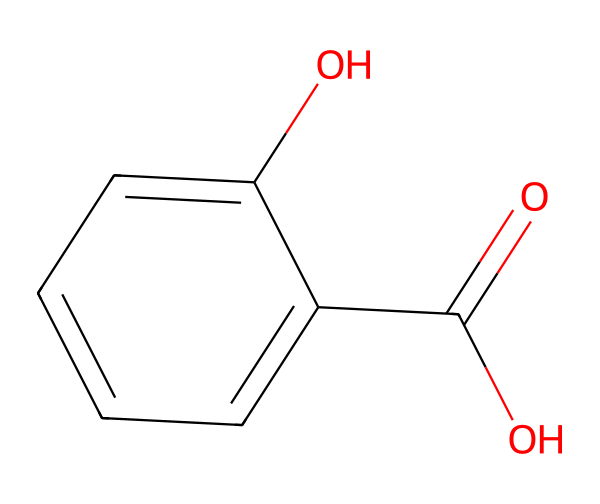What is the name of the acid represented by this structure? The structure shows a carboxylic acid group (–COOH) attached to a benzene ring, which identifies it as salicylic acid.
Answer: salicylic acid How many carbon atoms are present in salicylic acid? By analyzing the structure, there are seven carbon atoms present in the molecule: six in the benzene ring and one in the carboxylic acid group.
Answer: 7 What functional groups can be identified in this chemical? The structure includes a carboxylic acid group (–COOH) and a hydroxyl group (–OH) indicating two functional groups present in this acid.
Answer: carboxylic acid, hydroxyl Does salicylic acid have an aromatic ring? The structure includes a benzene ring, which is a classic example of an aromatic ring, confirming that salicylic acid is indeed aromatic.
Answer: yes What type of acid is salicylic acid classified as? Salicylic acid, having a carboxylic acid functional group, is classified as a simple carboxylic acid.
Answer: carboxylic acid What is the total number of oxygen atoms in salicylic acid? Upon inspecting the structure, there are two oxygen atoms in total: one in the carboxylic group and one in the hydroxyl group, thus counting both yields two oxygen atoms.
Answer: 2 How does the presence of the hydroxyl group affect solubility? The hydroxyl group increases the polarity of salicylic acid, enhancing its solubility in water due to hydrogen bonding capability.
Answer: increases solubility 